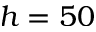<formula> <loc_0><loc_0><loc_500><loc_500>h = 5 0</formula> 